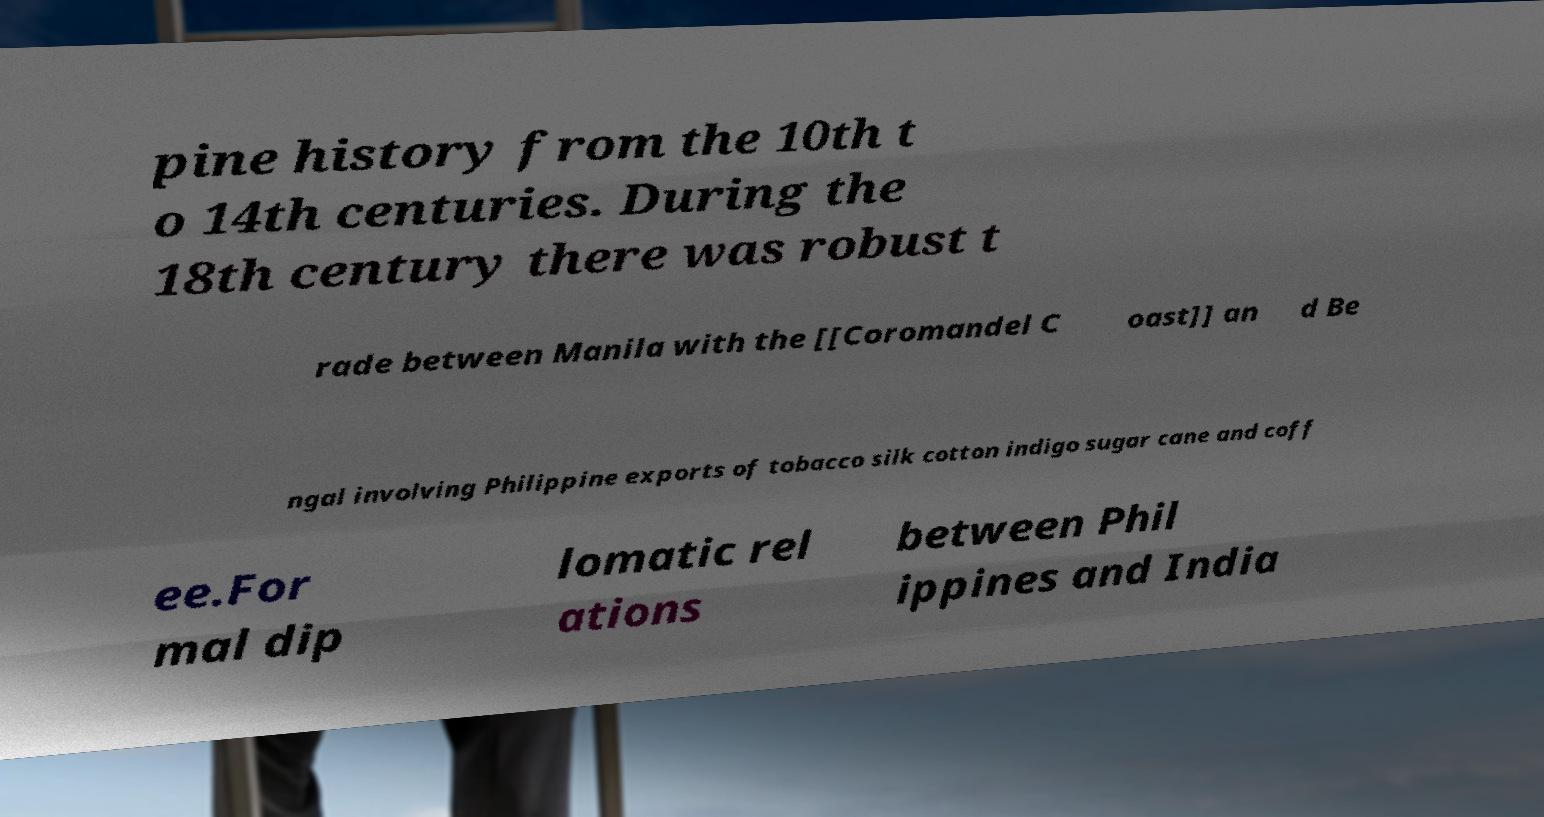I need the written content from this picture converted into text. Can you do that? pine history from the 10th t o 14th centuries. During the 18th century there was robust t rade between Manila with the [[Coromandel C oast]] an d Be ngal involving Philippine exports of tobacco silk cotton indigo sugar cane and coff ee.For mal dip lomatic rel ations between Phil ippines and India 